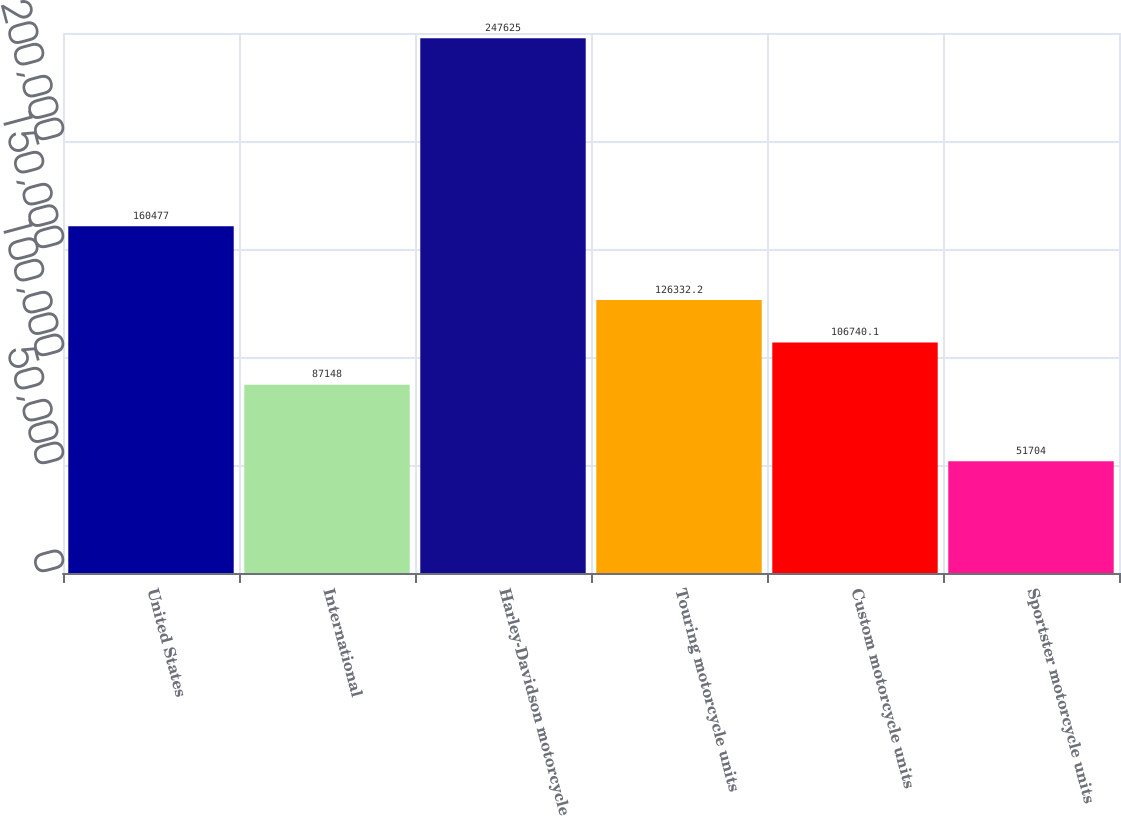Convert chart. <chart><loc_0><loc_0><loc_500><loc_500><bar_chart><fcel>United States<fcel>International<fcel>Harley-Davidson motorcycle<fcel>Touring motorcycle units<fcel>Custom motorcycle units<fcel>Sportster motorcycle units<nl><fcel>160477<fcel>87148<fcel>247625<fcel>126332<fcel>106740<fcel>51704<nl></chart> 